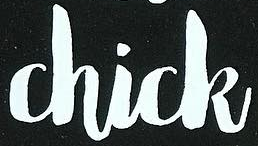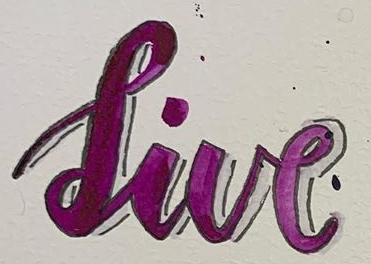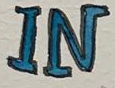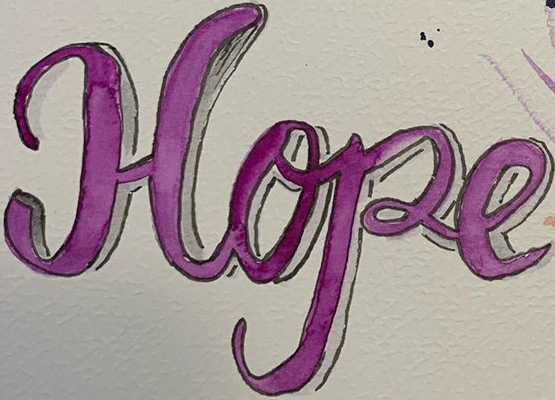What words are shown in these images in order, separated by a semicolon? Chick; live; IN; Hope 